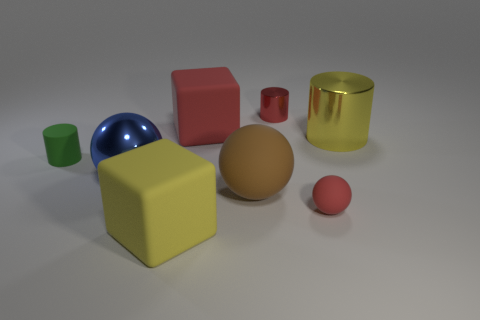Add 2 brown rubber balls. How many objects exist? 10 Subtract all cylinders. How many objects are left? 5 Add 5 big balls. How many big balls are left? 7 Add 5 red cubes. How many red cubes exist? 6 Subtract 0 purple cylinders. How many objects are left? 8 Subtract all large red rubber cubes. Subtract all small cyan things. How many objects are left? 7 